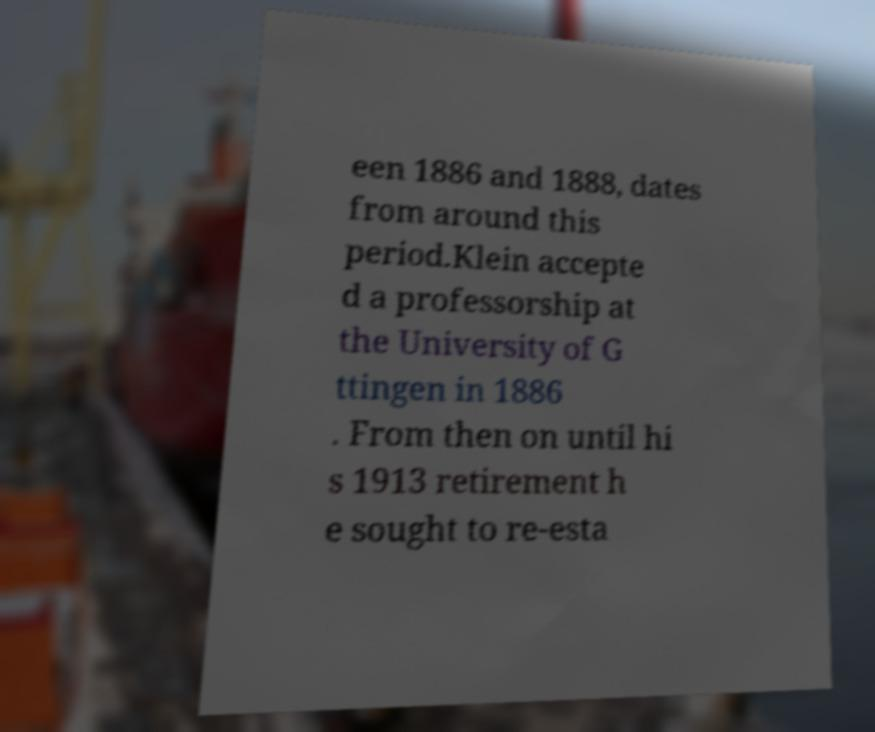Could you extract and type out the text from this image? een 1886 and 1888, dates from around this period.Klein accepte d a professorship at the University of G ttingen in 1886 . From then on until hi s 1913 retirement h e sought to re-esta 